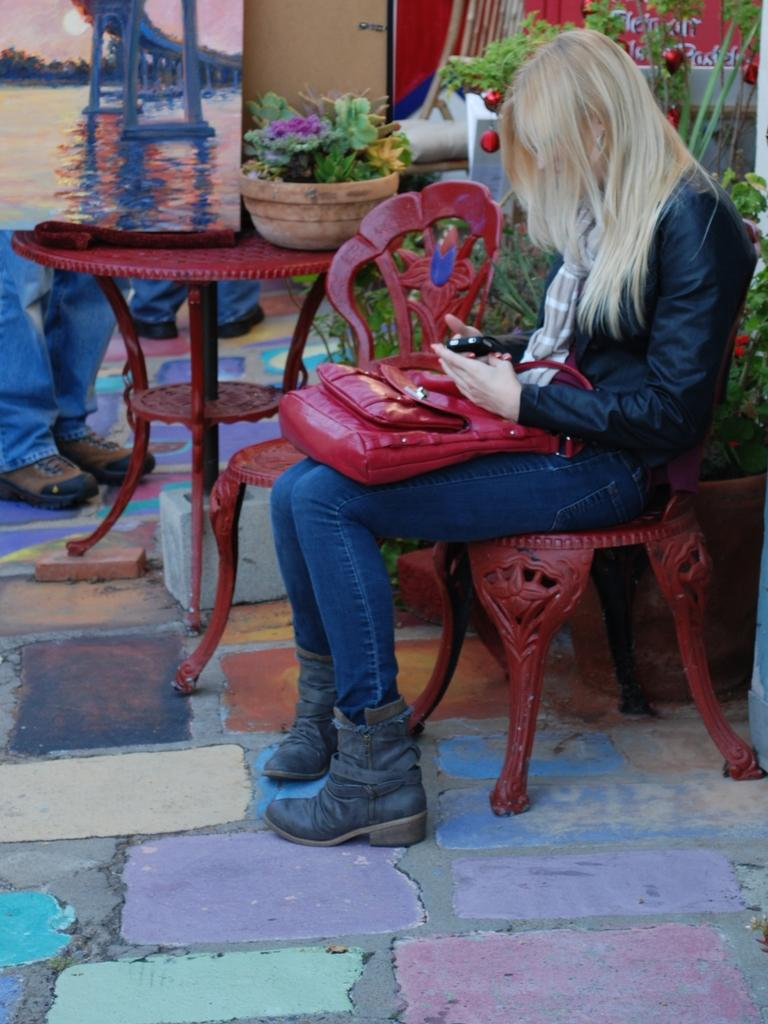Who is the main subject in the image? There is a lady in the image. What is the lady holding in the image? The lady is holding a bag. What is the lady sitting on in the image? The lady is sitting on a red chair. What can be seen in the background of the image? There are flower pots and paintings in the background of the image. What type of paste is the lady attempting to use in the image? There is no paste or any indication of an attempt to use paste in the image. 